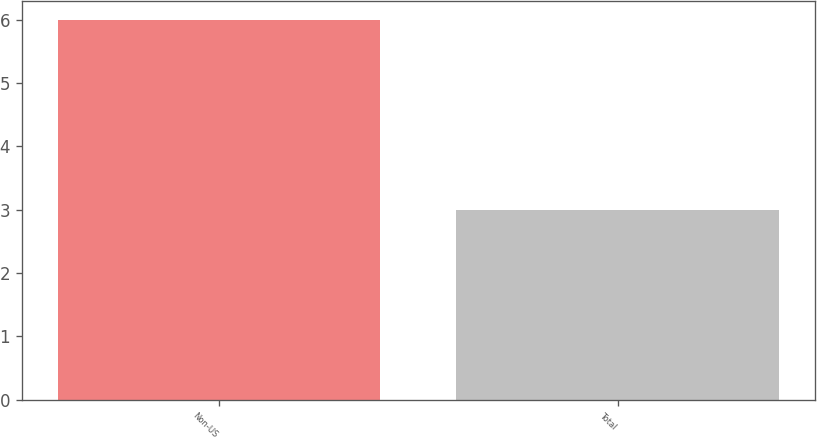<chart> <loc_0><loc_0><loc_500><loc_500><bar_chart><fcel>Non-US<fcel>Total<nl><fcel>6<fcel>3<nl></chart> 